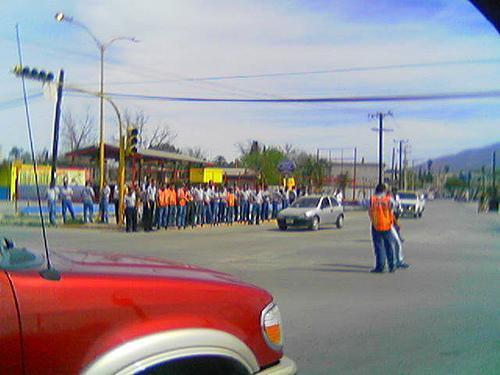How many traffic lights can be seen in the photo?
Give a very brief answer. 1. How many people are in the picture?
Give a very brief answer. 2. 